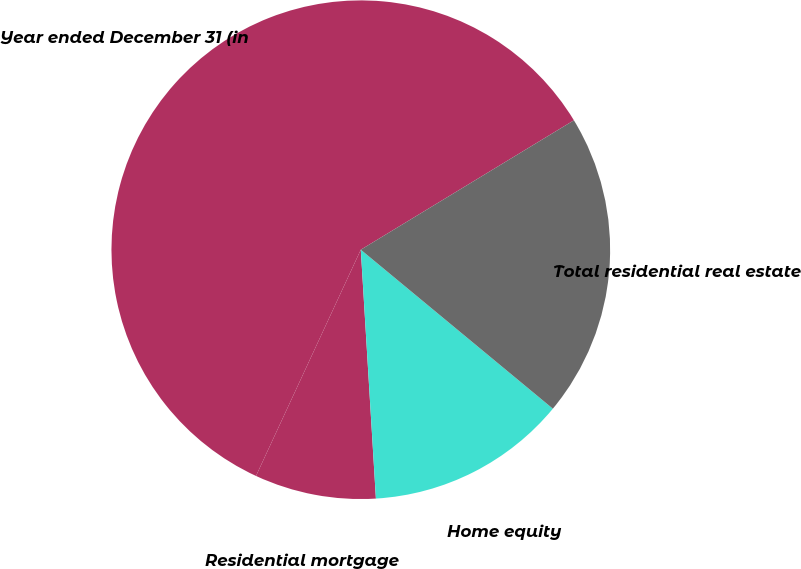Convert chart to OTSL. <chart><loc_0><loc_0><loc_500><loc_500><pie_chart><fcel>Year ended December 31 (in<fcel>Residential mortgage<fcel>Home equity<fcel>Total residential real estate<nl><fcel>59.41%<fcel>7.87%<fcel>13.03%<fcel>19.69%<nl></chart> 